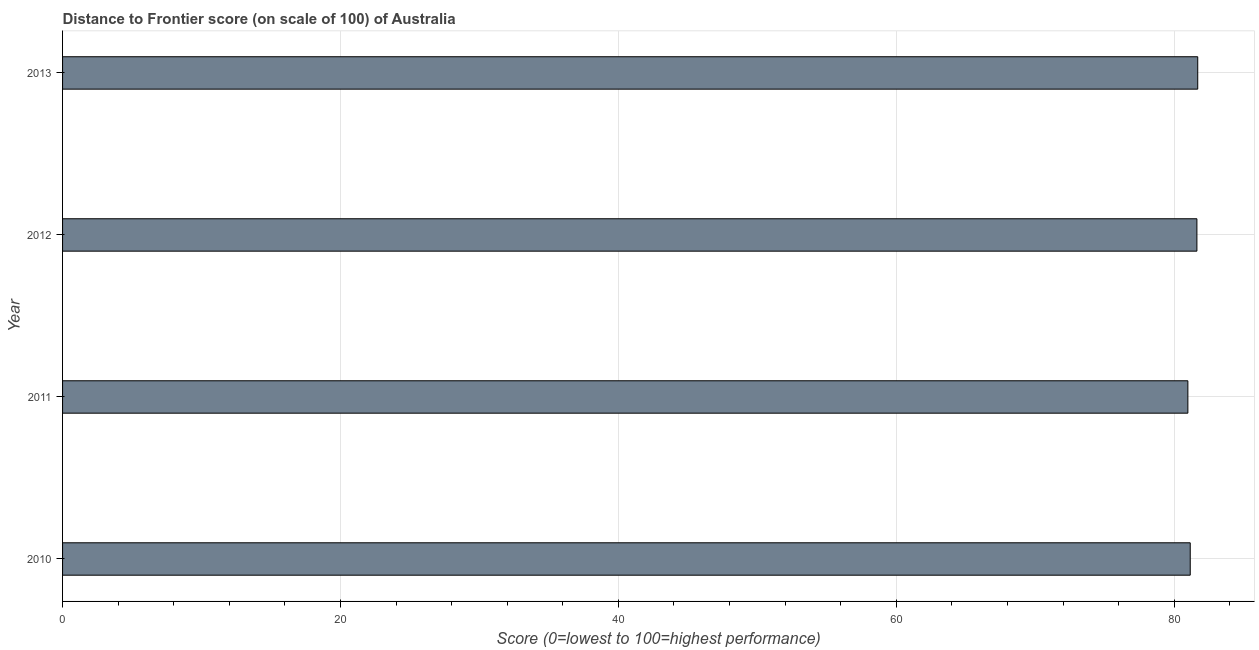Does the graph contain any zero values?
Provide a short and direct response. No. What is the title of the graph?
Your answer should be very brief. Distance to Frontier score (on scale of 100) of Australia. What is the label or title of the X-axis?
Give a very brief answer. Score (0=lowest to 100=highest performance). What is the distance to frontier score in 2012?
Ensure brevity in your answer.  81.63. Across all years, what is the maximum distance to frontier score?
Offer a terse response. 81.69. Across all years, what is the minimum distance to frontier score?
Provide a short and direct response. 80.98. In which year was the distance to frontier score maximum?
Your answer should be very brief. 2013. In which year was the distance to frontier score minimum?
Keep it short and to the point. 2011. What is the sum of the distance to frontier score?
Your response must be concise. 325.45. What is the difference between the distance to frontier score in 2010 and 2012?
Your answer should be compact. -0.48. What is the average distance to frontier score per year?
Provide a succinct answer. 81.36. What is the median distance to frontier score?
Your answer should be compact. 81.39. Do a majority of the years between 2013 and 2012 (inclusive) have distance to frontier score greater than 72 ?
Your response must be concise. No. What is the ratio of the distance to frontier score in 2010 to that in 2013?
Ensure brevity in your answer.  0.99. Is the distance to frontier score in 2010 less than that in 2013?
Offer a terse response. Yes. What is the difference between the highest and the second highest distance to frontier score?
Provide a short and direct response. 0.06. Is the sum of the distance to frontier score in 2012 and 2013 greater than the maximum distance to frontier score across all years?
Your response must be concise. Yes. What is the difference between the highest and the lowest distance to frontier score?
Give a very brief answer. 0.71. How many bars are there?
Ensure brevity in your answer.  4. Are all the bars in the graph horizontal?
Provide a succinct answer. Yes. Are the values on the major ticks of X-axis written in scientific E-notation?
Provide a short and direct response. No. What is the Score (0=lowest to 100=highest performance) of 2010?
Your answer should be compact. 81.15. What is the Score (0=lowest to 100=highest performance) of 2011?
Give a very brief answer. 80.98. What is the Score (0=lowest to 100=highest performance) in 2012?
Offer a terse response. 81.63. What is the Score (0=lowest to 100=highest performance) of 2013?
Keep it short and to the point. 81.69. What is the difference between the Score (0=lowest to 100=highest performance) in 2010 and 2011?
Your answer should be compact. 0.17. What is the difference between the Score (0=lowest to 100=highest performance) in 2010 and 2012?
Your answer should be very brief. -0.48. What is the difference between the Score (0=lowest to 100=highest performance) in 2010 and 2013?
Ensure brevity in your answer.  -0.54. What is the difference between the Score (0=lowest to 100=highest performance) in 2011 and 2012?
Offer a very short reply. -0.65. What is the difference between the Score (0=lowest to 100=highest performance) in 2011 and 2013?
Make the answer very short. -0.71. What is the difference between the Score (0=lowest to 100=highest performance) in 2012 and 2013?
Give a very brief answer. -0.06. What is the ratio of the Score (0=lowest to 100=highest performance) in 2010 to that in 2011?
Provide a short and direct response. 1. What is the ratio of the Score (0=lowest to 100=highest performance) in 2010 to that in 2012?
Offer a very short reply. 0.99. What is the ratio of the Score (0=lowest to 100=highest performance) in 2010 to that in 2013?
Offer a terse response. 0.99. What is the ratio of the Score (0=lowest to 100=highest performance) in 2011 to that in 2012?
Your answer should be compact. 0.99. What is the ratio of the Score (0=lowest to 100=highest performance) in 2011 to that in 2013?
Give a very brief answer. 0.99. What is the ratio of the Score (0=lowest to 100=highest performance) in 2012 to that in 2013?
Give a very brief answer. 1. 